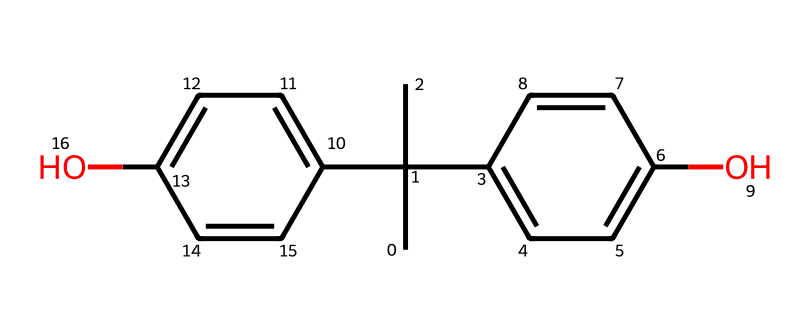how many carbon atoms are present in the chemical structure? By examining the SMILES representation, we can count the carbon (C) atoms in the structure. Each 'C' signifies a carbon atom, and upon analysis, there are a total of 15 carbon atoms.
Answer: 15 how many hydroxyl groups are present in the structure? The hydroxyl group (-OH) can be identified by looking for the 'O' in the structure followed by a carbon atom. Here, there are two occurrences of this arrangement in the chemical structure, indicating two hydroxyl groups.
Answer: 2 what type of functional groups are present in this chemical? The primary functional groups present in this compound are hydroxyl groups (indicated by the 'O' attached to 'H') which are characteristic of phenolic compounds, contributing to its properties.
Answer: hydroxyl is this chemical structure symmetric? To determine symmetry, we analyze the arrangement of atoms in the structure. The complex arrangement of rings and substituents reveals that the molecule does not possess perfect rotational symmetry; hence, it is asymmetrically structured.
Answer: no what is the parent compound related to this chemical structure? The chemical’s structure indicates that it is derived from bisphenol as suggested by the presence of two phenolic rings connected, characteristic of bisphenol A and its derivatives.
Answer: bisphenol A how many aromatic rings are present in the chemical structure? Aromatic rings can be identified by the presence of alternating double bonds within a cyclic structure. In this case, the chemical contains two aromatic rings evident in its structure, based on its substituent relationships and bonding structure.
Answer: 2 does this compound have any chiral centers? A chiral center is defined as a carbon atom that is bonded to four different substituents. By examining the carbon atoms in the structure, we find that there are no carbons with four distinct substituents, meaning there are no chiral centers present in the compound.
Answer: no 